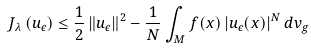<formula> <loc_0><loc_0><loc_500><loc_500>J _ { \lambda } \left ( u _ { \epsilon } \right ) \leq \frac { 1 } { 2 } \left \| u _ { \epsilon } \right \| ^ { 2 } - \frac { 1 } { N } \int _ { M } f ( x ) \left | u _ { \epsilon } ( x ) \right | ^ { N } d v _ { g }</formula> 